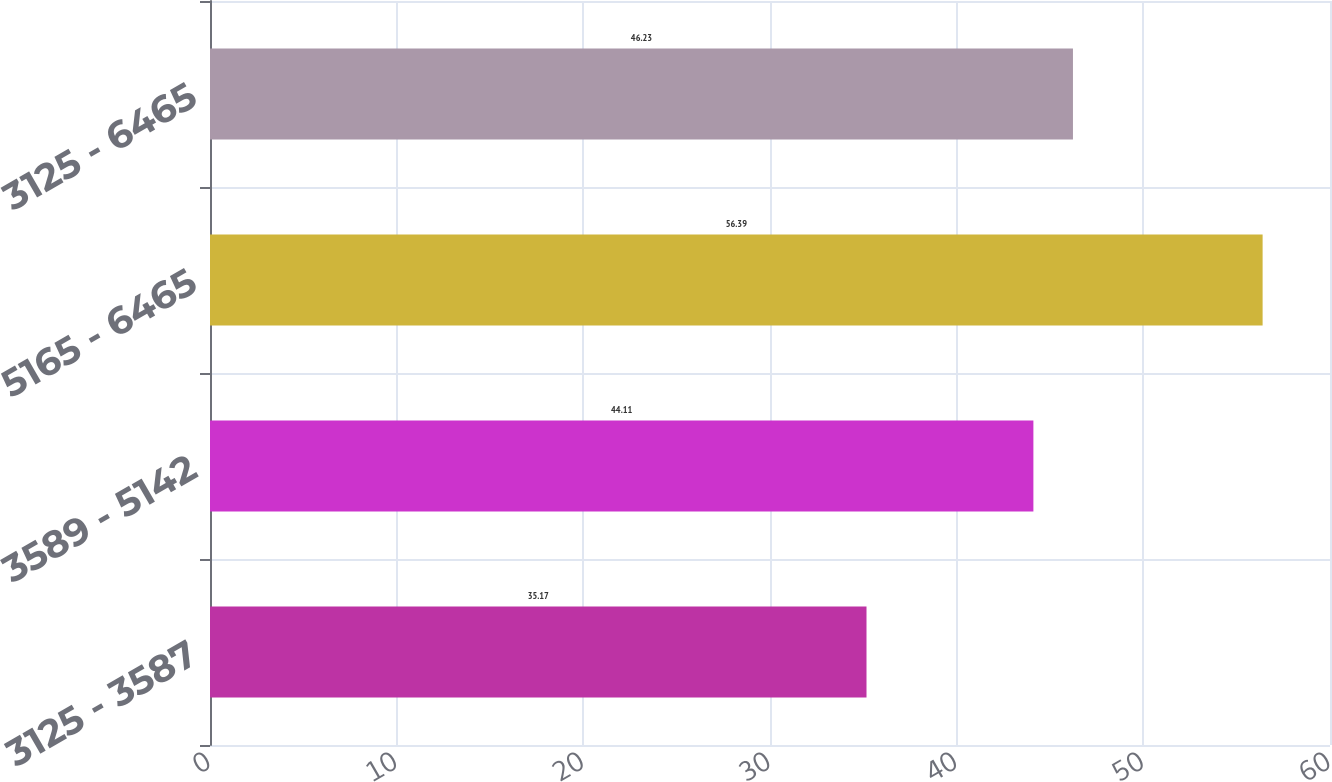<chart> <loc_0><loc_0><loc_500><loc_500><bar_chart><fcel>3125 - 3587<fcel>3589 - 5142<fcel>5165 - 6465<fcel>3125 - 6465<nl><fcel>35.17<fcel>44.11<fcel>56.39<fcel>46.23<nl></chart> 